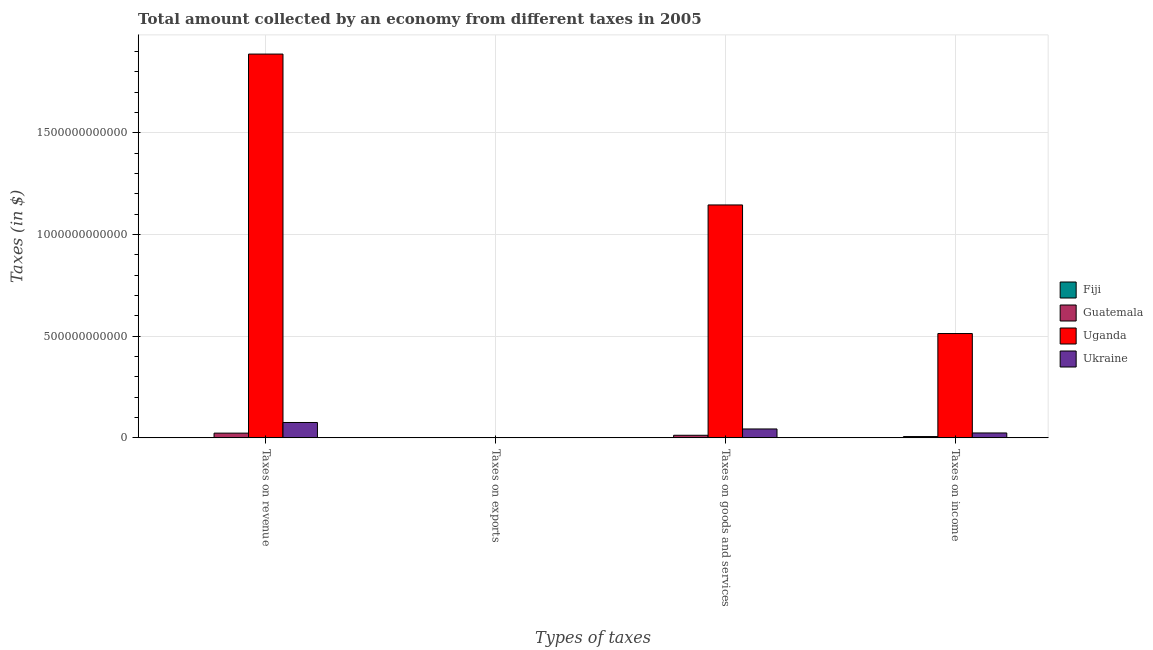How many different coloured bars are there?
Your answer should be very brief. 4. How many bars are there on the 2nd tick from the right?
Keep it short and to the point. 4. What is the label of the 4th group of bars from the left?
Ensure brevity in your answer.  Taxes on income. What is the amount collected as tax on exports in Fiji?
Make the answer very short. 1.14e+07. Across all countries, what is the maximum amount collected as tax on goods?
Provide a succinct answer. 1.15e+12. Across all countries, what is the minimum amount collected as tax on goods?
Provide a succinct answer. 4.91e+08. In which country was the amount collected as tax on goods maximum?
Ensure brevity in your answer.  Uganda. In which country was the amount collected as tax on exports minimum?
Give a very brief answer. Guatemala. What is the total amount collected as tax on income in the graph?
Make the answer very short. 5.44e+11. What is the difference between the amount collected as tax on goods in Uganda and that in Ukraine?
Offer a very short reply. 1.10e+12. What is the difference between the amount collected as tax on income in Uganda and the amount collected as tax on exports in Fiji?
Offer a very short reply. 5.13e+11. What is the average amount collected as tax on revenue per country?
Your answer should be very brief. 4.97e+11. What is the difference between the amount collected as tax on exports and amount collected as tax on revenue in Ukraine?
Your answer should be compact. -7.51e+1. What is the ratio of the amount collected as tax on income in Ukraine to that in Guatemala?
Ensure brevity in your answer.  3.74. What is the difference between the highest and the second highest amount collected as tax on revenue?
Your response must be concise. 1.81e+12. What is the difference between the highest and the lowest amount collected as tax on revenue?
Your answer should be very brief. 1.89e+12. In how many countries, is the amount collected as tax on revenue greater than the average amount collected as tax on revenue taken over all countries?
Give a very brief answer. 1. What does the 4th bar from the left in Taxes on exports represents?
Offer a very short reply. Ukraine. What does the 2nd bar from the right in Taxes on revenue represents?
Give a very brief answer. Uganda. Are all the bars in the graph horizontal?
Give a very brief answer. No. How many countries are there in the graph?
Offer a very short reply. 4. What is the difference between two consecutive major ticks on the Y-axis?
Your answer should be compact. 5.00e+11. Are the values on the major ticks of Y-axis written in scientific E-notation?
Make the answer very short. No. Does the graph contain any zero values?
Your answer should be very brief. No. What is the title of the graph?
Keep it short and to the point. Total amount collected by an economy from different taxes in 2005. What is the label or title of the X-axis?
Ensure brevity in your answer.  Types of taxes. What is the label or title of the Y-axis?
Your answer should be compact. Taxes (in $). What is the Taxes (in $) in Fiji in Taxes on revenue?
Your answer should be very brief. 1.09e+09. What is the Taxes (in $) of Guatemala in Taxes on revenue?
Your response must be concise. 2.33e+1. What is the Taxes (in $) of Uganda in Taxes on revenue?
Ensure brevity in your answer.  1.89e+12. What is the Taxes (in $) in Ukraine in Taxes on revenue?
Offer a very short reply. 7.56e+1. What is the Taxes (in $) of Fiji in Taxes on exports?
Offer a terse response. 1.14e+07. What is the Taxes (in $) in Guatemala in Taxes on exports?
Your answer should be compact. 9.30e+05. What is the Taxes (in $) in Uganda in Taxes on exports?
Keep it short and to the point. 1.14e+09. What is the Taxes (in $) in Ukraine in Taxes on exports?
Make the answer very short. 5.20e+08. What is the Taxes (in $) in Fiji in Taxes on goods and services?
Provide a short and direct response. 4.91e+08. What is the Taxes (in $) in Guatemala in Taxes on goods and services?
Give a very brief answer. 1.28e+1. What is the Taxes (in $) of Uganda in Taxes on goods and services?
Provide a short and direct response. 1.15e+12. What is the Taxes (in $) in Ukraine in Taxes on goods and services?
Keep it short and to the point. 4.38e+1. What is the Taxes (in $) of Fiji in Taxes on income?
Provide a succinct answer. 3.52e+08. What is the Taxes (in $) of Guatemala in Taxes on income?
Your response must be concise. 6.44e+09. What is the Taxes (in $) in Uganda in Taxes on income?
Ensure brevity in your answer.  5.13e+11. What is the Taxes (in $) of Ukraine in Taxes on income?
Offer a terse response. 2.41e+1. Across all Types of taxes, what is the maximum Taxes (in $) in Fiji?
Offer a terse response. 1.09e+09. Across all Types of taxes, what is the maximum Taxes (in $) of Guatemala?
Offer a very short reply. 2.33e+1. Across all Types of taxes, what is the maximum Taxes (in $) in Uganda?
Your answer should be very brief. 1.89e+12. Across all Types of taxes, what is the maximum Taxes (in $) in Ukraine?
Give a very brief answer. 7.56e+1. Across all Types of taxes, what is the minimum Taxes (in $) in Fiji?
Provide a short and direct response. 1.14e+07. Across all Types of taxes, what is the minimum Taxes (in $) of Guatemala?
Give a very brief answer. 9.30e+05. Across all Types of taxes, what is the minimum Taxes (in $) of Uganda?
Provide a succinct answer. 1.14e+09. Across all Types of taxes, what is the minimum Taxes (in $) in Ukraine?
Offer a very short reply. 5.20e+08. What is the total Taxes (in $) in Fiji in the graph?
Give a very brief answer. 1.94e+09. What is the total Taxes (in $) of Guatemala in the graph?
Your answer should be very brief. 4.25e+1. What is the total Taxes (in $) of Uganda in the graph?
Ensure brevity in your answer.  3.55e+12. What is the total Taxes (in $) of Ukraine in the graph?
Provide a succinct answer. 1.44e+11. What is the difference between the Taxes (in $) in Fiji in Taxes on revenue and that in Taxes on exports?
Make the answer very short. 1.07e+09. What is the difference between the Taxes (in $) of Guatemala in Taxes on revenue and that in Taxes on exports?
Your response must be concise. 2.33e+1. What is the difference between the Taxes (in $) in Uganda in Taxes on revenue and that in Taxes on exports?
Keep it short and to the point. 1.89e+12. What is the difference between the Taxes (in $) of Ukraine in Taxes on revenue and that in Taxes on exports?
Your answer should be compact. 7.51e+1. What is the difference between the Taxes (in $) in Fiji in Taxes on revenue and that in Taxes on goods and services?
Offer a terse response. 5.94e+08. What is the difference between the Taxes (in $) of Guatemala in Taxes on revenue and that in Taxes on goods and services?
Provide a succinct answer. 1.05e+1. What is the difference between the Taxes (in $) of Uganda in Taxes on revenue and that in Taxes on goods and services?
Offer a terse response. 7.42e+11. What is the difference between the Taxes (in $) in Ukraine in Taxes on revenue and that in Taxes on goods and services?
Give a very brief answer. 3.18e+1. What is the difference between the Taxes (in $) of Fiji in Taxes on revenue and that in Taxes on income?
Offer a terse response. 7.33e+08. What is the difference between the Taxes (in $) in Guatemala in Taxes on revenue and that in Taxes on income?
Your answer should be very brief. 1.68e+1. What is the difference between the Taxes (in $) of Uganda in Taxes on revenue and that in Taxes on income?
Give a very brief answer. 1.37e+12. What is the difference between the Taxes (in $) in Ukraine in Taxes on revenue and that in Taxes on income?
Provide a succinct answer. 5.15e+1. What is the difference between the Taxes (in $) of Fiji in Taxes on exports and that in Taxes on goods and services?
Your answer should be very brief. -4.80e+08. What is the difference between the Taxes (in $) in Guatemala in Taxes on exports and that in Taxes on goods and services?
Ensure brevity in your answer.  -1.28e+1. What is the difference between the Taxes (in $) in Uganda in Taxes on exports and that in Taxes on goods and services?
Offer a very short reply. -1.14e+12. What is the difference between the Taxes (in $) in Ukraine in Taxes on exports and that in Taxes on goods and services?
Offer a terse response. -4.33e+1. What is the difference between the Taxes (in $) in Fiji in Taxes on exports and that in Taxes on income?
Keep it short and to the point. -3.41e+08. What is the difference between the Taxes (in $) of Guatemala in Taxes on exports and that in Taxes on income?
Offer a terse response. -6.44e+09. What is the difference between the Taxes (in $) in Uganda in Taxes on exports and that in Taxes on income?
Provide a succinct answer. -5.12e+11. What is the difference between the Taxes (in $) of Ukraine in Taxes on exports and that in Taxes on income?
Provide a short and direct response. -2.36e+1. What is the difference between the Taxes (in $) in Fiji in Taxes on goods and services and that in Taxes on income?
Provide a succinct answer. 1.39e+08. What is the difference between the Taxes (in $) in Guatemala in Taxes on goods and services and that in Taxes on income?
Your response must be concise. 6.36e+09. What is the difference between the Taxes (in $) of Uganda in Taxes on goods and services and that in Taxes on income?
Your response must be concise. 6.32e+11. What is the difference between the Taxes (in $) in Ukraine in Taxes on goods and services and that in Taxes on income?
Ensure brevity in your answer.  1.97e+1. What is the difference between the Taxes (in $) in Fiji in Taxes on revenue and the Taxes (in $) in Guatemala in Taxes on exports?
Give a very brief answer. 1.08e+09. What is the difference between the Taxes (in $) of Fiji in Taxes on revenue and the Taxes (in $) of Uganda in Taxes on exports?
Offer a terse response. -5.36e+07. What is the difference between the Taxes (in $) in Fiji in Taxes on revenue and the Taxes (in $) in Ukraine in Taxes on exports?
Provide a short and direct response. 5.65e+08. What is the difference between the Taxes (in $) in Guatemala in Taxes on revenue and the Taxes (in $) in Uganda in Taxes on exports?
Make the answer very short. 2.21e+1. What is the difference between the Taxes (in $) of Guatemala in Taxes on revenue and the Taxes (in $) of Ukraine in Taxes on exports?
Your response must be concise. 2.28e+1. What is the difference between the Taxes (in $) in Uganda in Taxes on revenue and the Taxes (in $) in Ukraine in Taxes on exports?
Offer a very short reply. 1.89e+12. What is the difference between the Taxes (in $) of Fiji in Taxes on revenue and the Taxes (in $) of Guatemala in Taxes on goods and services?
Offer a very short reply. -1.17e+1. What is the difference between the Taxes (in $) of Fiji in Taxes on revenue and the Taxes (in $) of Uganda in Taxes on goods and services?
Your answer should be very brief. -1.14e+12. What is the difference between the Taxes (in $) of Fiji in Taxes on revenue and the Taxes (in $) of Ukraine in Taxes on goods and services?
Keep it short and to the point. -4.27e+1. What is the difference between the Taxes (in $) of Guatemala in Taxes on revenue and the Taxes (in $) of Uganda in Taxes on goods and services?
Offer a terse response. -1.12e+12. What is the difference between the Taxes (in $) in Guatemala in Taxes on revenue and the Taxes (in $) in Ukraine in Taxes on goods and services?
Your answer should be very brief. -2.05e+1. What is the difference between the Taxes (in $) in Uganda in Taxes on revenue and the Taxes (in $) in Ukraine in Taxes on goods and services?
Provide a succinct answer. 1.84e+12. What is the difference between the Taxes (in $) of Fiji in Taxes on revenue and the Taxes (in $) of Guatemala in Taxes on income?
Offer a terse response. -5.35e+09. What is the difference between the Taxes (in $) in Fiji in Taxes on revenue and the Taxes (in $) in Uganda in Taxes on income?
Your answer should be very brief. -5.12e+11. What is the difference between the Taxes (in $) of Fiji in Taxes on revenue and the Taxes (in $) of Ukraine in Taxes on income?
Your answer should be very brief. -2.30e+1. What is the difference between the Taxes (in $) in Guatemala in Taxes on revenue and the Taxes (in $) in Uganda in Taxes on income?
Keep it short and to the point. -4.90e+11. What is the difference between the Taxes (in $) in Guatemala in Taxes on revenue and the Taxes (in $) in Ukraine in Taxes on income?
Keep it short and to the point. -8.34e+08. What is the difference between the Taxes (in $) in Uganda in Taxes on revenue and the Taxes (in $) in Ukraine in Taxes on income?
Give a very brief answer. 1.86e+12. What is the difference between the Taxes (in $) in Fiji in Taxes on exports and the Taxes (in $) in Guatemala in Taxes on goods and services?
Give a very brief answer. -1.28e+1. What is the difference between the Taxes (in $) in Fiji in Taxes on exports and the Taxes (in $) in Uganda in Taxes on goods and services?
Give a very brief answer. -1.15e+12. What is the difference between the Taxes (in $) in Fiji in Taxes on exports and the Taxes (in $) in Ukraine in Taxes on goods and services?
Offer a very short reply. -4.38e+1. What is the difference between the Taxes (in $) in Guatemala in Taxes on exports and the Taxes (in $) in Uganda in Taxes on goods and services?
Ensure brevity in your answer.  -1.15e+12. What is the difference between the Taxes (in $) of Guatemala in Taxes on exports and the Taxes (in $) of Ukraine in Taxes on goods and services?
Make the answer very short. -4.38e+1. What is the difference between the Taxes (in $) of Uganda in Taxes on exports and the Taxes (in $) of Ukraine in Taxes on goods and services?
Offer a very short reply. -4.27e+1. What is the difference between the Taxes (in $) of Fiji in Taxes on exports and the Taxes (in $) of Guatemala in Taxes on income?
Provide a succinct answer. -6.43e+09. What is the difference between the Taxes (in $) in Fiji in Taxes on exports and the Taxes (in $) in Uganda in Taxes on income?
Your answer should be compact. -5.13e+11. What is the difference between the Taxes (in $) of Fiji in Taxes on exports and the Taxes (in $) of Ukraine in Taxes on income?
Give a very brief answer. -2.41e+1. What is the difference between the Taxes (in $) of Guatemala in Taxes on exports and the Taxes (in $) of Uganda in Taxes on income?
Make the answer very short. -5.13e+11. What is the difference between the Taxes (in $) in Guatemala in Taxes on exports and the Taxes (in $) in Ukraine in Taxes on income?
Your answer should be very brief. -2.41e+1. What is the difference between the Taxes (in $) in Uganda in Taxes on exports and the Taxes (in $) in Ukraine in Taxes on income?
Your answer should be very brief. -2.30e+1. What is the difference between the Taxes (in $) of Fiji in Taxes on goods and services and the Taxes (in $) of Guatemala in Taxes on income?
Give a very brief answer. -5.95e+09. What is the difference between the Taxes (in $) of Fiji in Taxes on goods and services and the Taxes (in $) of Uganda in Taxes on income?
Keep it short and to the point. -5.13e+11. What is the difference between the Taxes (in $) in Fiji in Taxes on goods and services and the Taxes (in $) in Ukraine in Taxes on income?
Your answer should be very brief. -2.36e+1. What is the difference between the Taxes (in $) in Guatemala in Taxes on goods and services and the Taxes (in $) in Uganda in Taxes on income?
Give a very brief answer. -5.00e+11. What is the difference between the Taxes (in $) of Guatemala in Taxes on goods and services and the Taxes (in $) of Ukraine in Taxes on income?
Your response must be concise. -1.13e+1. What is the difference between the Taxes (in $) in Uganda in Taxes on goods and services and the Taxes (in $) in Ukraine in Taxes on income?
Ensure brevity in your answer.  1.12e+12. What is the average Taxes (in $) in Fiji per Types of taxes?
Offer a very short reply. 4.85e+08. What is the average Taxes (in $) of Guatemala per Types of taxes?
Offer a very short reply. 1.06e+1. What is the average Taxes (in $) in Uganda per Types of taxes?
Your answer should be compact. 8.87e+11. What is the average Taxes (in $) of Ukraine per Types of taxes?
Your answer should be compact. 3.60e+1. What is the difference between the Taxes (in $) of Fiji and Taxes (in $) of Guatemala in Taxes on revenue?
Offer a very short reply. -2.22e+1. What is the difference between the Taxes (in $) of Fiji and Taxes (in $) of Uganda in Taxes on revenue?
Your answer should be very brief. -1.89e+12. What is the difference between the Taxes (in $) of Fiji and Taxes (in $) of Ukraine in Taxes on revenue?
Your response must be concise. -7.45e+1. What is the difference between the Taxes (in $) in Guatemala and Taxes (in $) in Uganda in Taxes on revenue?
Provide a short and direct response. -1.86e+12. What is the difference between the Taxes (in $) in Guatemala and Taxes (in $) in Ukraine in Taxes on revenue?
Your answer should be compact. -5.23e+1. What is the difference between the Taxes (in $) of Uganda and Taxes (in $) of Ukraine in Taxes on revenue?
Your response must be concise. 1.81e+12. What is the difference between the Taxes (in $) in Fiji and Taxes (in $) in Guatemala in Taxes on exports?
Give a very brief answer. 1.05e+07. What is the difference between the Taxes (in $) in Fiji and Taxes (in $) in Uganda in Taxes on exports?
Offer a very short reply. -1.13e+09. What is the difference between the Taxes (in $) of Fiji and Taxes (in $) of Ukraine in Taxes on exports?
Provide a succinct answer. -5.09e+08. What is the difference between the Taxes (in $) of Guatemala and Taxes (in $) of Uganda in Taxes on exports?
Your answer should be compact. -1.14e+09. What is the difference between the Taxes (in $) in Guatemala and Taxes (in $) in Ukraine in Taxes on exports?
Ensure brevity in your answer.  -5.20e+08. What is the difference between the Taxes (in $) of Uganda and Taxes (in $) of Ukraine in Taxes on exports?
Your answer should be very brief. 6.19e+08. What is the difference between the Taxes (in $) in Fiji and Taxes (in $) in Guatemala in Taxes on goods and services?
Offer a very short reply. -1.23e+1. What is the difference between the Taxes (in $) of Fiji and Taxes (in $) of Uganda in Taxes on goods and services?
Make the answer very short. -1.15e+12. What is the difference between the Taxes (in $) of Fiji and Taxes (in $) of Ukraine in Taxes on goods and services?
Make the answer very short. -4.33e+1. What is the difference between the Taxes (in $) in Guatemala and Taxes (in $) in Uganda in Taxes on goods and services?
Provide a short and direct response. -1.13e+12. What is the difference between the Taxes (in $) in Guatemala and Taxes (in $) in Ukraine in Taxes on goods and services?
Make the answer very short. -3.10e+1. What is the difference between the Taxes (in $) of Uganda and Taxes (in $) of Ukraine in Taxes on goods and services?
Make the answer very short. 1.10e+12. What is the difference between the Taxes (in $) of Fiji and Taxes (in $) of Guatemala in Taxes on income?
Provide a succinct answer. -6.09e+09. What is the difference between the Taxes (in $) of Fiji and Taxes (in $) of Uganda in Taxes on income?
Offer a very short reply. -5.13e+11. What is the difference between the Taxes (in $) of Fiji and Taxes (in $) of Ukraine in Taxes on income?
Offer a terse response. -2.38e+1. What is the difference between the Taxes (in $) of Guatemala and Taxes (in $) of Uganda in Taxes on income?
Your answer should be very brief. -5.07e+11. What is the difference between the Taxes (in $) of Guatemala and Taxes (in $) of Ukraine in Taxes on income?
Keep it short and to the point. -1.77e+1. What is the difference between the Taxes (in $) of Uganda and Taxes (in $) of Ukraine in Taxes on income?
Your answer should be very brief. 4.89e+11. What is the ratio of the Taxes (in $) in Fiji in Taxes on revenue to that in Taxes on exports?
Your answer should be very brief. 94.88. What is the ratio of the Taxes (in $) of Guatemala in Taxes on revenue to that in Taxes on exports?
Your response must be concise. 2.50e+04. What is the ratio of the Taxes (in $) of Uganda in Taxes on revenue to that in Taxes on exports?
Provide a succinct answer. 1657.07. What is the ratio of the Taxes (in $) of Ukraine in Taxes on revenue to that in Taxes on exports?
Offer a terse response. 145.23. What is the ratio of the Taxes (in $) of Fiji in Taxes on revenue to that in Taxes on goods and services?
Ensure brevity in your answer.  2.21. What is the ratio of the Taxes (in $) in Guatemala in Taxes on revenue to that in Taxes on goods and services?
Ensure brevity in your answer.  1.82. What is the ratio of the Taxes (in $) of Uganda in Taxes on revenue to that in Taxes on goods and services?
Give a very brief answer. 1.65. What is the ratio of the Taxes (in $) of Ukraine in Taxes on revenue to that in Taxes on goods and services?
Give a very brief answer. 1.73. What is the ratio of the Taxes (in $) in Fiji in Taxes on revenue to that in Taxes on income?
Keep it short and to the point. 3.08. What is the ratio of the Taxes (in $) of Guatemala in Taxes on revenue to that in Taxes on income?
Your answer should be very brief. 3.62. What is the ratio of the Taxes (in $) in Uganda in Taxes on revenue to that in Taxes on income?
Your answer should be compact. 3.68. What is the ratio of the Taxes (in $) in Ukraine in Taxes on revenue to that in Taxes on income?
Keep it short and to the point. 3.14. What is the ratio of the Taxes (in $) in Fiji in Taxes on exports to that in Taxes on goods and services?
Make the answer very short. 0.02. What is the ratio of the Taxes (in $) of Ukraine in Taxes on exports to that in Taxes on goods and services?
Provide a short and direct response. 0.01. What is the ratio of the Taxes (in $) of Fiji in Taxes on exports to that in Taxes on income?
Keep it short and to the point. 0.03. What is the ratio of the Taxes (in $) in Guatemala in Taxes on exports to that in Taxes on income?
Provide a succinct answer. 0. What is the ratio of the Taxes (in $) of Uganda in Taxes on exports to that in Taxes on income?
Make the answer very short. 0. What is the ratio of the Taxes (in $) in Ukraine in Taxes on exports to that in Taxes on income?
Ensure brevity in your answer.  0.02. What is the ratio of the Taxes (in $) in Fiji in Taxes on goods and services to that in Taxes on income?
Your response must be concise. 1.39. What is the ratio of the Taxes (in $) of Guatemala in Taxes on goods and services to that in Taxes on income?
Your answer should be very brief. 1.99. What is the ratio of the Taxes (in $) of Uganda in Taxes on goods and services to that in Taxes on income?
Make the answer very short. 2.23. What is the ratio of the Taxes (in $) of Ukraine in Taxes on goods and services to that in Taxes on income?
Provide a short and direct response. 1.82. What is the difference between the highest and the second highest Taxes (in $) of Fiji?
Offer a terse response. 5.94e+08. What is the difference between the highest and the second highest Taxes (in $) in Guatemala?
Your answer should be very brief. 1.05e+1. What is the difference between the highest and the second highest Taxes (in $) in Uganda?
Provide a succinct answer. 7.42e+11. What is the difference between the highest and the second highest Taxes (in $) in Ukraine?
Keep it short and to the point. 3.18e+1. What is the difference between the highest and the lowest Taxes (in $) in Fiji?
Provide a short and direct response. 1.07e+09. What is the difference between the highest and the lowest Taxes (in $) of Guatemala?
Give a very brief answer. 2.33e+1. What is the difference between the highest and the lowest Taxes (in $) in Uganda?
Ensure brevity in your answer.  1.89e+12. What is the difference between the highest and the lowest Taxes (in $) in Ukraine?
Your answer should be very brief. 7.51e+1. 